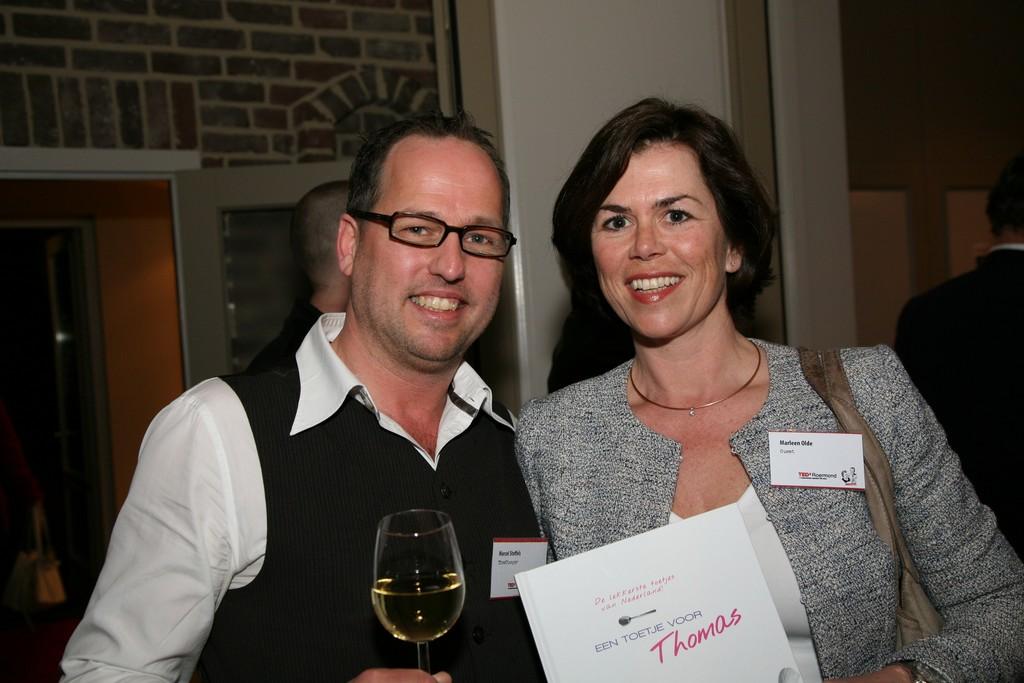What name is displayed on her name tag?
Keep it short and to the point. Marleen olde. What name is on the certificate?
Provide a short and direct response. Thomas. 